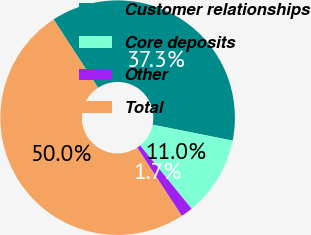Convert chart to OTSL. <chart><loc_0><loc_0><loc_500><loc_500><pie_chart><fcel>Customer relationships<fcel>Core deposits<fcel>Other<fcel>Total<nl><fcel>37.33%<fcel>11.01%<fcel>1.65%<fcel>50.0%<nl></chart> 